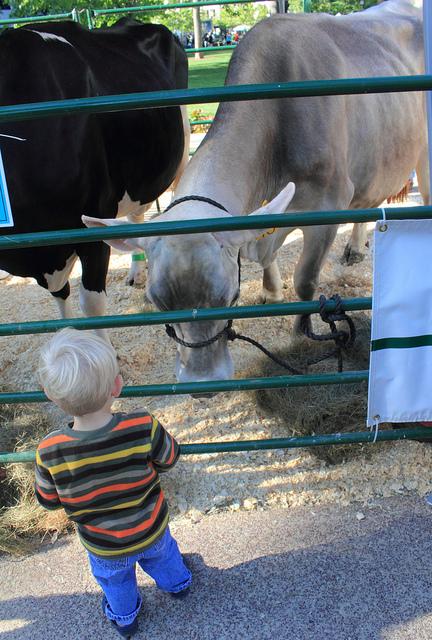What animal is here?
Write a very short answer. Cow. Is the baby standing alone?
Be succinct. Yes. Is that a kind of man?
Quick response, please. Yes. 